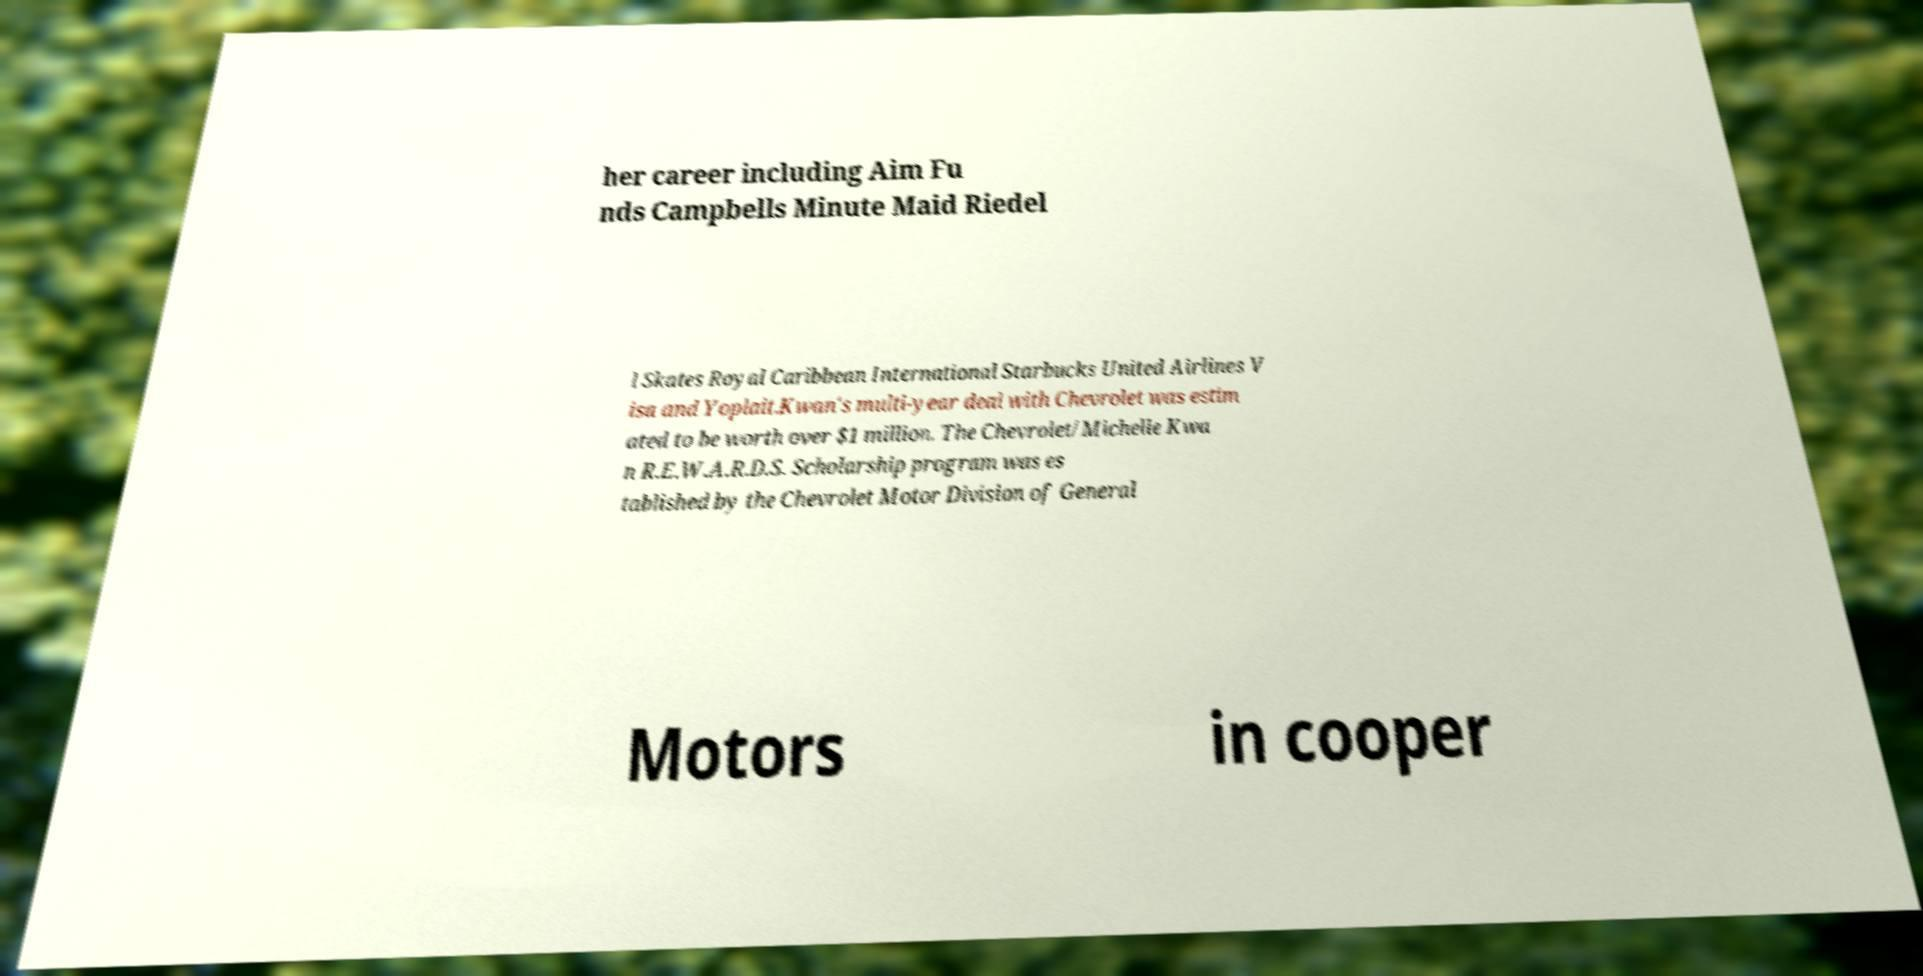Could you extract and type out the text from this image? her career including Aim Fu nds Campbells Minute Maid Riedel l Skates Royal Caribbean International Starbucks United Airlines V isa and Yoplait.Kwan's multi-year deal with Chevrolet was estim ated to be worth over $1 million. The Chevrolet/Michelle Kwa n R.E.W.A.R.D.S. Scholarship program was es tablished by the Chevrolet Motor Division of General Motors in cooper 